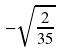<formula> <loc_0><loc_0><loc_500><loc_500>- \sqrt { \frac { 2 } { 3 5 } }</formula> 